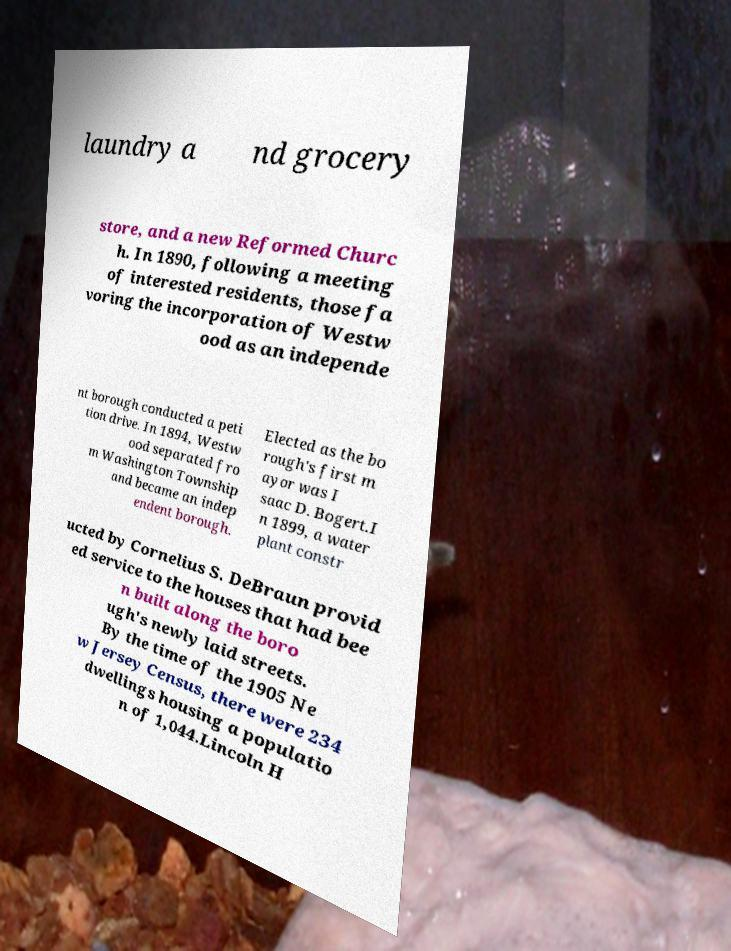What messages or text are displayed in this image? I need them in a readable, typed format. laundry a nd grocery store, and a new Reformed Churc h. In 1890, following a meeting of interested residents, those fa voring the incorporation of Westw ood as an independe nt borough conducted a peti tion drive. In 1894, Westw ood separated fro m Washington Township and became an indep endent borough. Elected as the bo rough's first m ayor was I saac D. Bogert.I n 1899, a water plant constr ucted by Cornelius S. DeBraun provid ed service to the houses that had bee n built along the boro ugh's newly laid streets. By the time of the 1905 Ne w Jersey Census, there were 234 dwellings housing a populatio n of 1,044.Lincoln H 